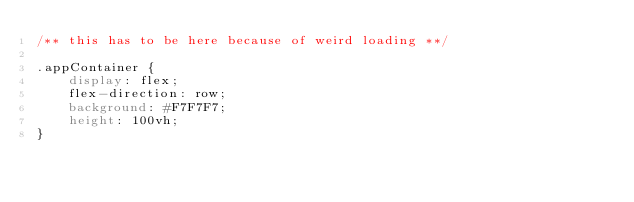Convert code to text. <code><loc_0><loc_0><loc_500><loc_500><_CSS_>/** this has to be here because of weird loading **/

.appContainer {
    display: flex;
    flex-direction: row;
    background: #F7F7F7;
    height: 100vh;
}
</code> 